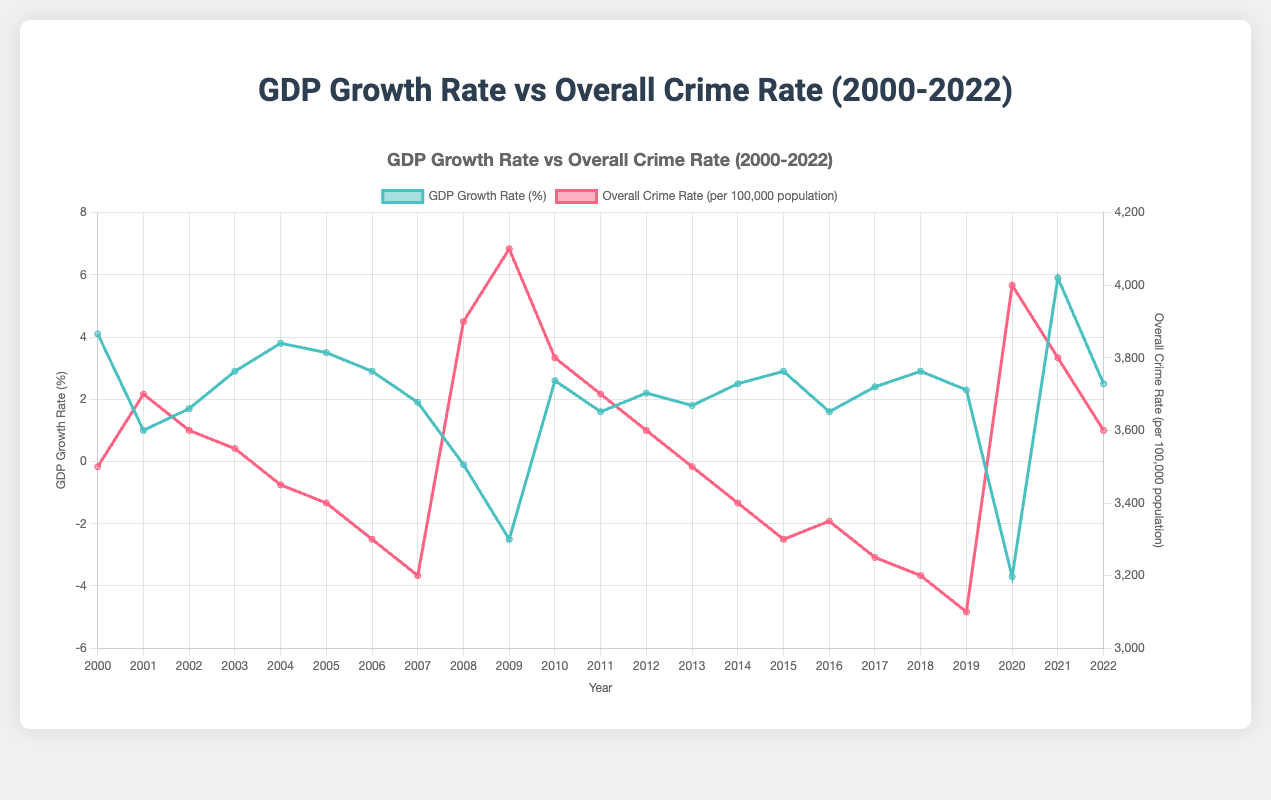What was the overall crime rate when the GDP growth rate was the lowest? Identify the year with the lowest GDP growth rate which is -3.7% in 2020, then refer to the crime rate for that year.
Answer: 4000 What is the average GDP growth rate from 2000 to 2022? Add the GDP growth rates for all the years and then divide by the number of years. Sum: 53.4, Count: 23, Average: 53.4/23
Answer: 2.32 How did the overall crime rate compare between the years 2008 and 2009? Look at the crime rates for 2008 (3900) and 2009 (4100) and compare them.
Answer: Higher in 2009 Which year had a higher GDP growth rate: 2004 or 2018? Look at the GDP growth rates for 2004 (3.8%) and 2018 (2.9%) and compare them.
Answer: 2004 During which year did the GDP growth rate and overall crime rate show the most significant changes compared to the previous year? Identify the year where the difference between consecutive GDP growth rates and crime rates is the largest. GDP: Biggest drop from 2008 to 2009 (-2.4), Crime: Biggest increase from 2008 to 2009 (200)
Answer: 2009 What is the overall trend in crime rates when GDP growth rates are negative? Identify the years with negative GDP growth rates and check the corresponding crime rates. Negative: 2008, 2009, 2020; Crime rates: 3900, 4100, 4000. The trend is an increase in crime rates.
Answer: Increasing trend What color represents the overall crime rate in the chart? Look at the graph to identify the color used for the overall crime rate line.
Answer: Red Which year had the highest overall crime rate, and what was the GDP growth rate that year? Identify the year with the highest crime rate (4100 in 2009) and then check the GDP growth rate for that year.
Answer: 2009, -2.5% Is there a visual trend indicating a relationship between high GDP growth rates and crime rates? Examine periods of high GDP growth rates like 2000, 2021, and check the corresponding crime rate trends to observe any patterns. Generally, high GDP growth correlates with lower crime rates.
Answer: Generally inverse trend 